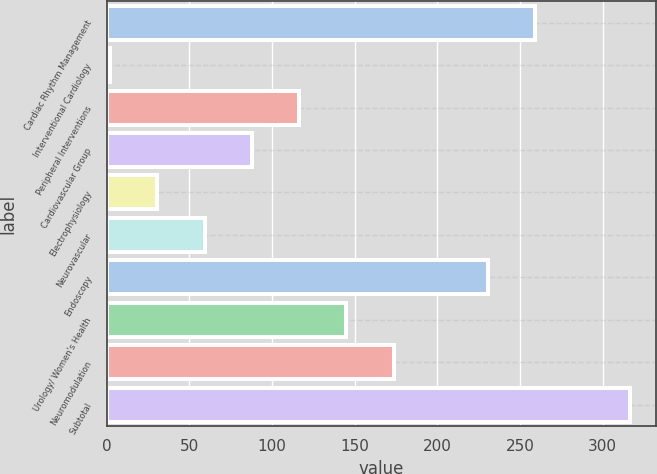<chart> <loc_0><loc_0><loc_500><loc_500><bar_chart><fcel>Cardiac Rhythm Management<fcel>Interventional Cardiology<fcel>Peripheral Interventions<fcel>Cardiovascular Group<fcel>Electrophysiology<fcel>Neurovascular<fcel>Endoscopy<fcel>Urology/ Women's Health<fcel>Neuromodulation<fcel>Subtotal<nl><fcel>259.4<fcel>2<fcel>116.4<fcel>87.8<fcel>30.6<fcel>59.2<fcel>230.8<fcel>145<fcel>173.6<fcel>316.6<nl></chart> 